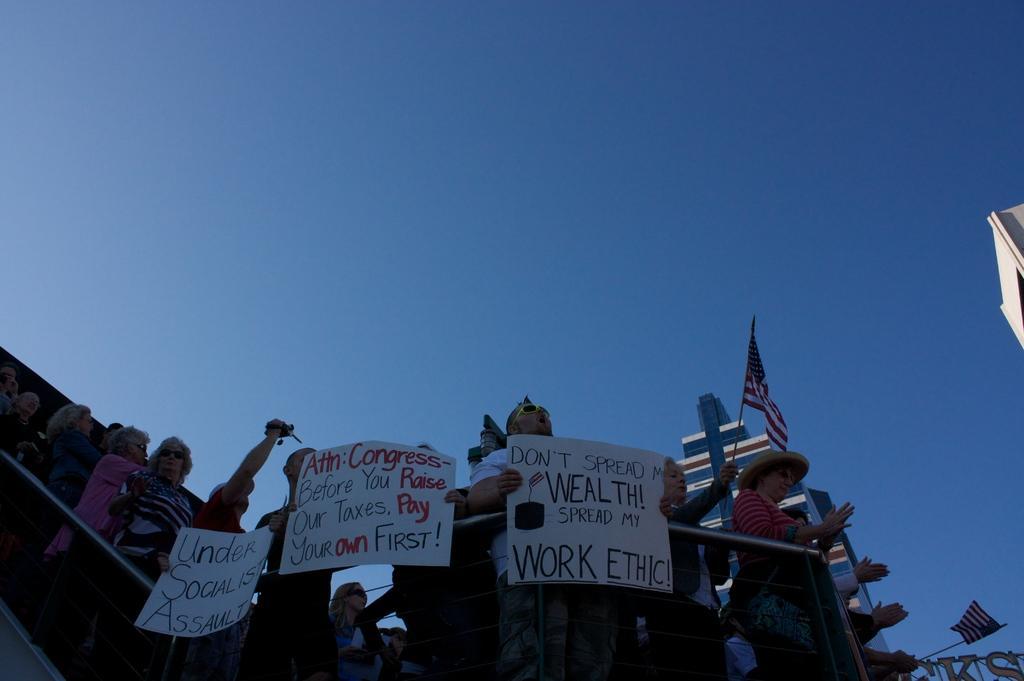How would you summarize this image in a sentence or two? In this image there are so many people standing and holding papers with some text on it and few are holding flags, one of them is holding a camera. On the bottom right side of the image we can see a metal structure with alphabets and there is a building. In the background there is the sky. 